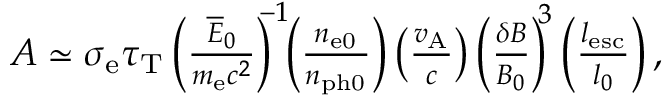Convert formula to latex. <formula><loc_0><loc_0><loc_500><loc_500>\begin{array} { r } { A \simeq \sigma _ { e } \tau _ { T } \left ( \frac { \overline { E } _ { 0 } } { m _ { e } c ^ { 2 } } \right ) ^ { \, - 1 } \, \left ( \frac { n _ { e 0 } } { n _ { p h 0 } } \right ) \left ( \frac { v _ { A } } { c } \right ) \left ( \frac { \delta B } { B _ { 0 } } \right ) ^ { \, 3 } \left ( \frac { l _ { e s c } } { l _ { 0 } } \right ) , } \end{array}</formula> 